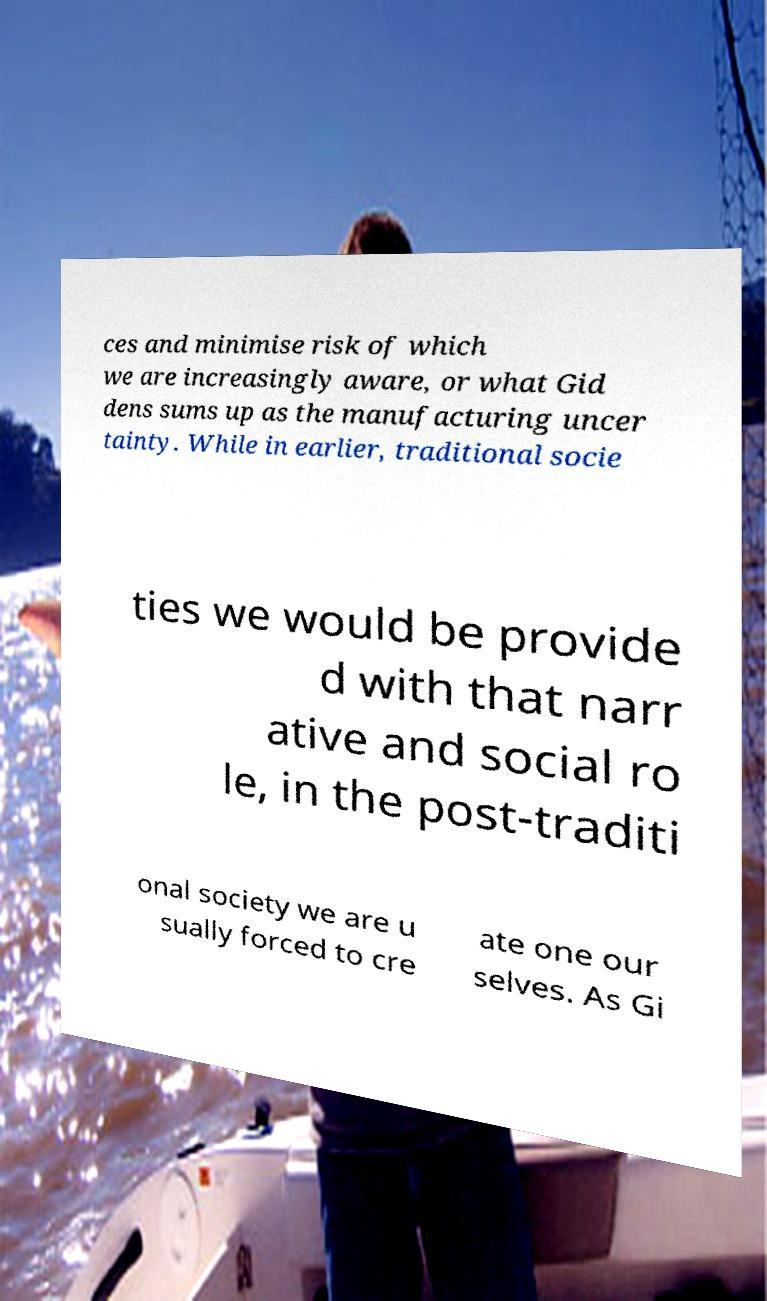What messages or text are displayed in this image? I need them in a readable, typed format. ces and minimise risk of which we are increasingly aware, or what Gid dens sums up as the manufacturing uncer tainty. While in earlier, traditional socie ties we would be provide d with that narr ative and social ro le, in the post-traditi onal society we are u sually forced to cre ate one our selves. As Gi 